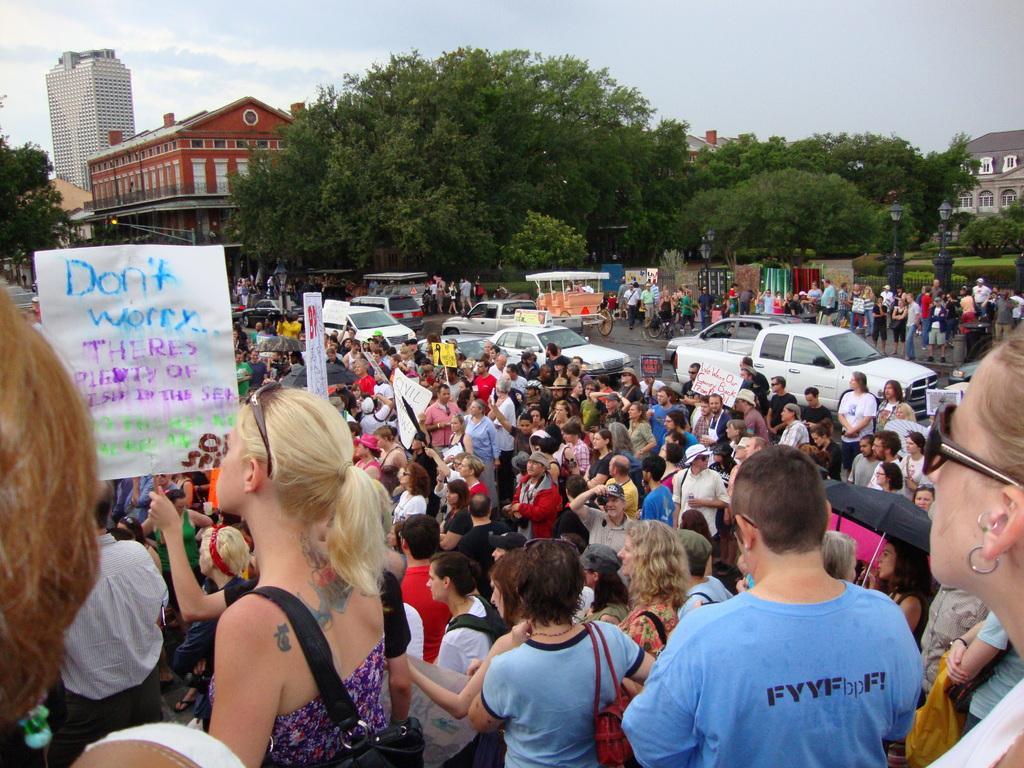In one or two sentences, can you explain what this image depicts? In this image, we can see persons wearing clothes. There are some persons holding boards with their hands. There are some trees in the middle of the image. There are buildings in the top left and in the top right of the image. There is a sky at the top of the image. 